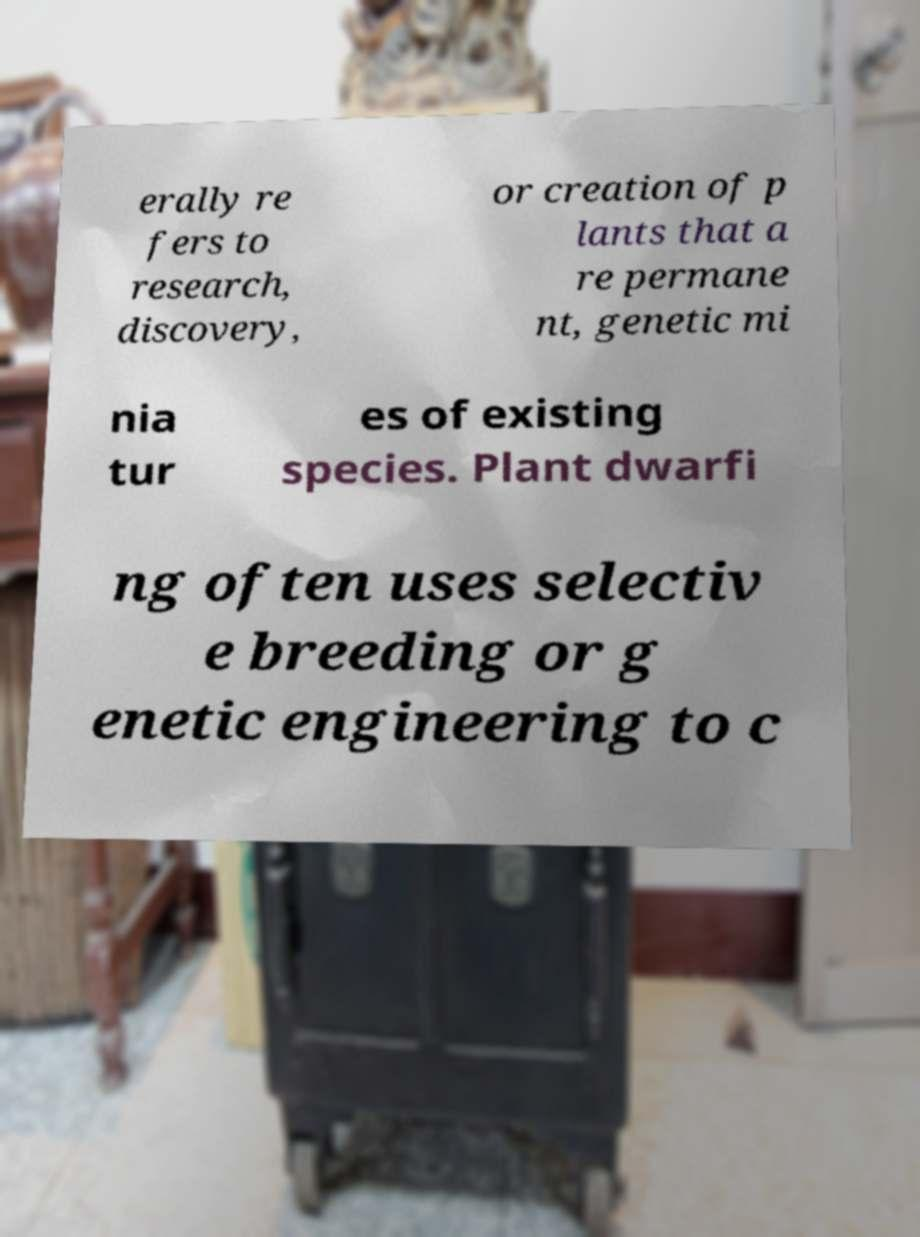Can you accurately transcribe the text from the provided image for me? erally re fers to research, discovery, or creation of p lants that a re permane nt, genetic mi nia tur es of existing species. Plant dwarfi ng often uses selectiv e breeding or g enetic engineering to c 